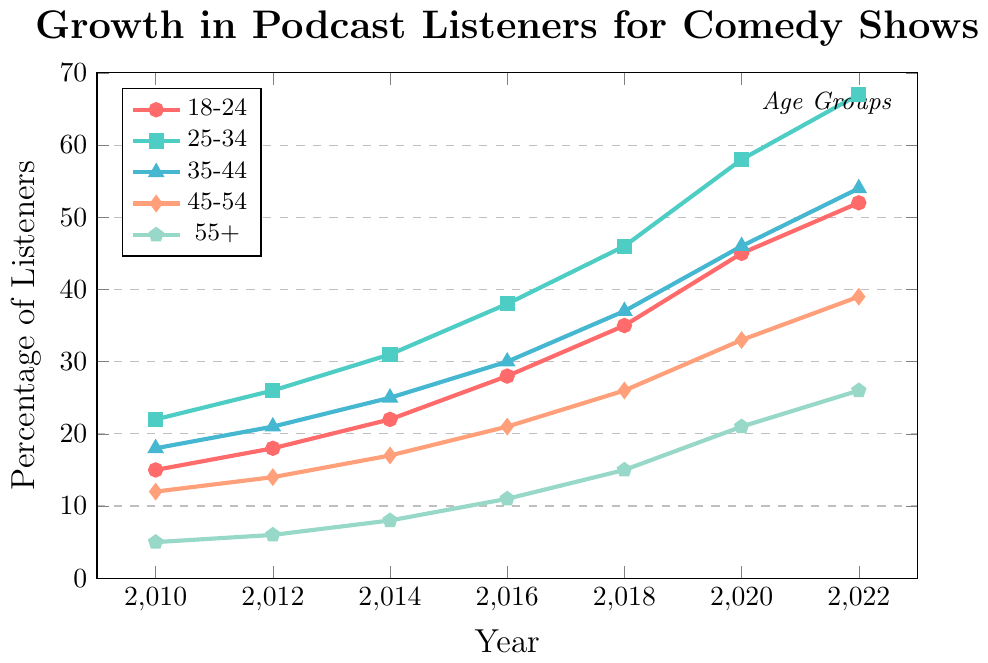What's the trend in podcast listeners for the 25-34 age group from 2010 to 2022? In 2010, the percentage was 22%, and it increased steadily in each subsequent period, reaching 67% by 2022.
Answer: Steady increase Which age group had the largest increase in podcast listeners between 2010 and 2022? The percentage of listeners for the 25-34 age group grew from 22% in 2010 to 67% in 2022, which is an increase of 45 percentage points, the largest among all age groups.
Answer: 25-34 By how many percentage points did the listenership for the 18-24 age group increase from 2018 to 2022? The percentage of listeners for the 18-24 age group was 35% in 2018 and 52% in 2022, making for an increase of 17 percentage points.
Answer: 17 In which year did the 35-44 age group surpass the 25-34 age group in podcast listeners? At no point does the 35-44 age group surpass the 25-34 age group based on the figure. The 25-34 age group always has a higher percentage of listeners than the 35-44 age group.
Answer: Never Compare the rate of growth in podcast listeners for the 45-54 age group with that of the 55+ age group from 2010 to 2022. Which group showed a higher growth rate? From 2010 to 2022, the 45-54 age group grew from 12% to 39% (an increase of 27 percentage points), while the 55+ age group grew from 5% to 26% (an increase of 21 percentage points). Hence, the 45-54 age group showed a higher growth rate.
Answer: 45-54 age group What is the difference in the percentage of podcast listeners between the 35-44 age group and the 55+ age group in 2022? In 2022, the percentage for the 35-44 age group is 54% and for the 55+ age group is 26%. The difference between them is 28 percentage points.
Answer: 28 Identify the year when the 18-24 age group had the same percentage of podcast listeners as the 45-54 age group had in 2018. The 18-24 age group had 26% podcast listeners in 2012. The 45-54 age group had 26% listeners in 2018, which matches the 18-24 age group's percentage from 2012.
Answer: 2018 How much higher was the percentage of listeners in the 25-34 age group compared to the 35-44 age group in the year 2020? In 2020, the percentage for the 25-34 age group was 58%, and for the 35-44 age group, it was 46%, making the difference 12 percentage points.
Answer: 12 What color represents the 55+ age group in the plot? The color representing the 55+ age group can be identified by looking at the plot's legend, which shows it's marked with the color green.
Answer: Green 